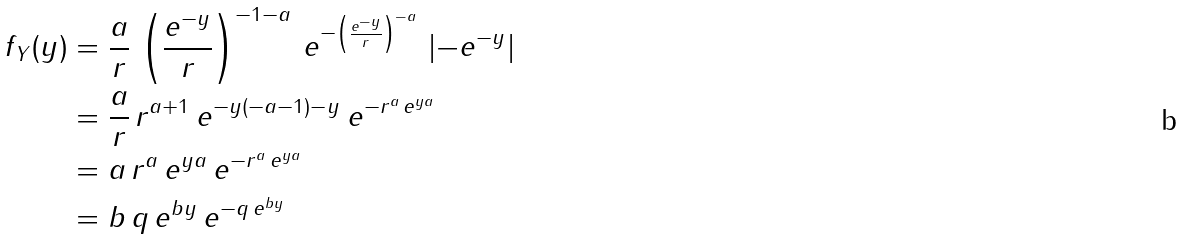<formula> <loc_0><loc_0><loc_500><loc_500>f _ { Y } ( y ) & = \frac { a } { r } \, \left ( \frac { e ^ { - y } } { r } \right ) ^ { - 1 - a } \, e ^ { - \left ( \frac { e ^ { - y } } { r } \right ) ^ { - a } } \, \left | - e ^ { - y } \right | \\ & = \frac { a } { r } \, r ^ { a + 1 } \, e ^ { - y ( - a - 1 ) - y } \, e ^ { - r ^ { a } \, e ^ { y a } } \\ & = a \, r ^ { a } \, e ^ { y a } \, e ^ { - r ^ { a } \, e ^ { y a } } \\ & = b \, q \, e ^ { b y } \, e ^ { - q \, e ^ { b y } }</formula> 